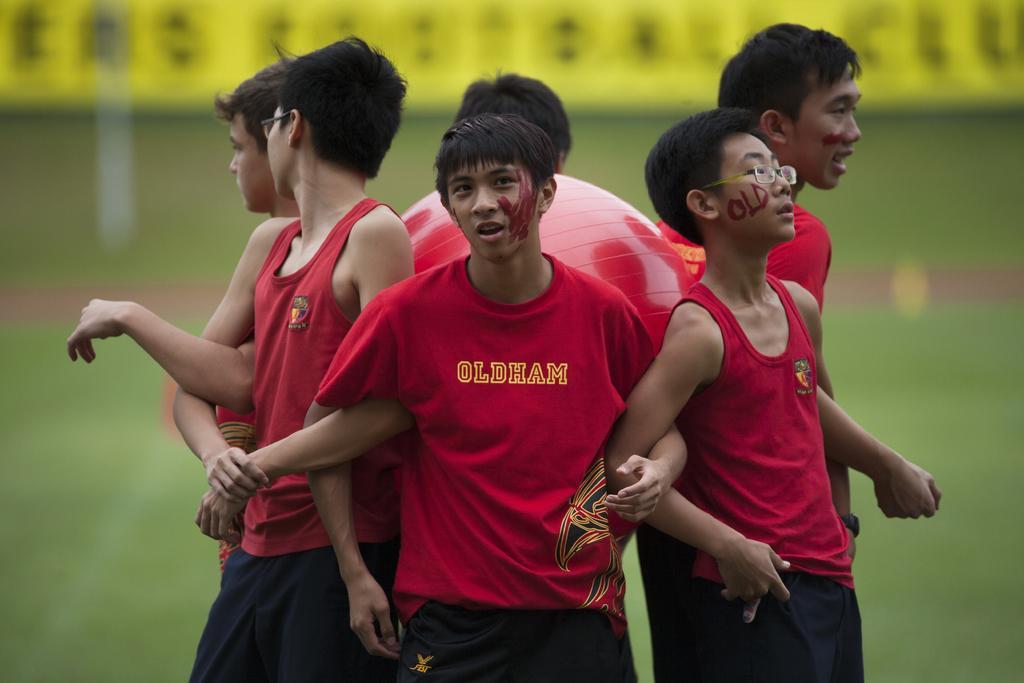Please provide a concise description of this image. In the image we can see there are kids standing around the gas ball. 